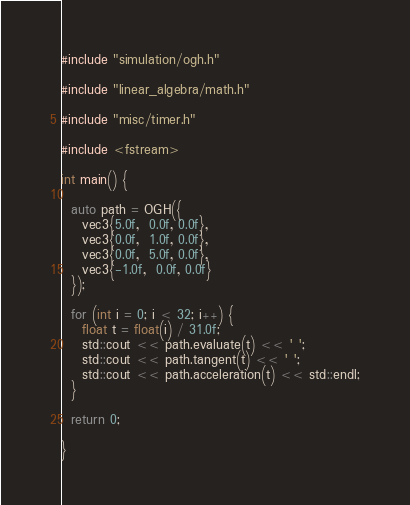<code> <loc_0><loc_0><loc_500><loc_500><_C++_>#include "simulation/ogh.h"

#include "linear_algebra/math.h"

#include "misc/timer.h"

#include <fstream>

int main() {

  auto path = OGH({
    vec3{5.0f,  0.0f, 0.0f},
    vec3{0.0f,  1.0f, 0.0f},
    vec3{0.0f,  5.0f, 0.0f},
    vec3{-1.0f,  0.0f, 0.0f}
  });

  for (int i = 0; i < 32; i++) {
    float t = float(i) / 31.0f;
    std::cout << path.evaluate(t) << ' ';
    std::cout << path.tangent(t) << ' ';
    std::cout << path.acceleration(t) << std::endl;
  }

  return 0;

}
</code> 